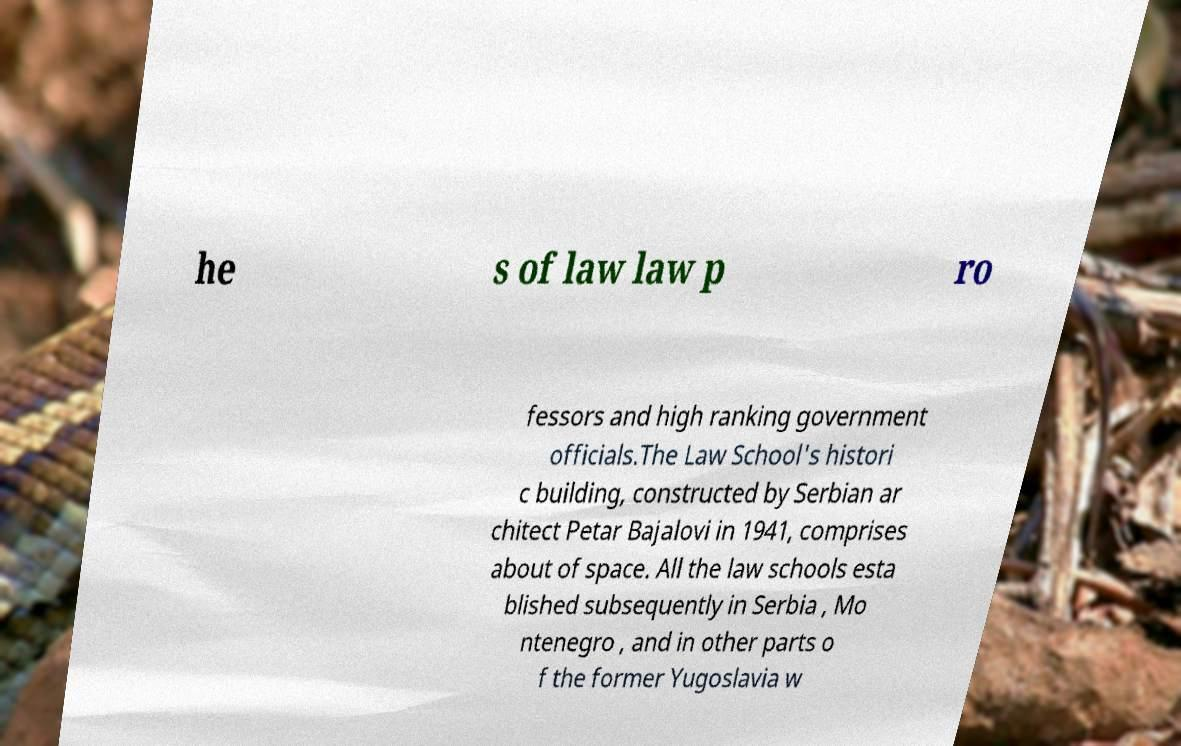Please identify and transcribe the text found in this image. he s of law law p ro fessors and high ranking government officials.The Law School's histori c building, constructed by Serbian ar chitect Petar Bajalovi in 1941, comprises about of space. All the law schools esta blished subsequently in Serbia , Mo ntenegro , and in other parts o f the former Yugoslavia w 